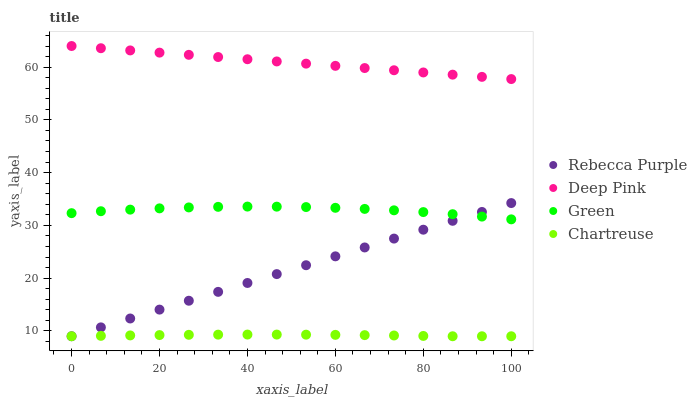Does Chartreuse have the minimum area under the curve?
Answer yes or no. Yes. Does Deep Pink have the maximum area under the curve?
Answer yes or no. Yes. Does Green have the minimum area under the curve?
Answer yes or no. No. Does Green have the maximum area under the curve?
Answer yes or no. No. Is Deep Pink the smoothest?
Answer yes or no. Yes. Is Green the roughest?
Answer yes or no. Yes. Is Green the smoothest?
Answer yes or no. No. Is Deep Pink the roughest?
Answer yes or no. No. Does Chartreuse have the lowest value?
Answer yes or no. Yes. Does Green have the lowest value?
Answer yes or no. No. Does Deep Pink have the highest value?
Answer yes or no. Yes. Does Green have the highest value?
Answer yes or no. No. Is Chartreuse less than Deep Pink?
Answer yes or no. Yes. Is Deep Pink greater than Rebecca Purple?
Answer yes or no. Yes. Does Rebecca Purple intersect Chartreuse?
Answer yes or no. Yes. Is Rebecca Purple less than Chartreuse?
Answer yes or no. No. Is Rebecca Purple greater than Chartreuse?
Answer yes or no. No. Does Chartreuse intersect Deep Pink?
Answer yes or no. No. 